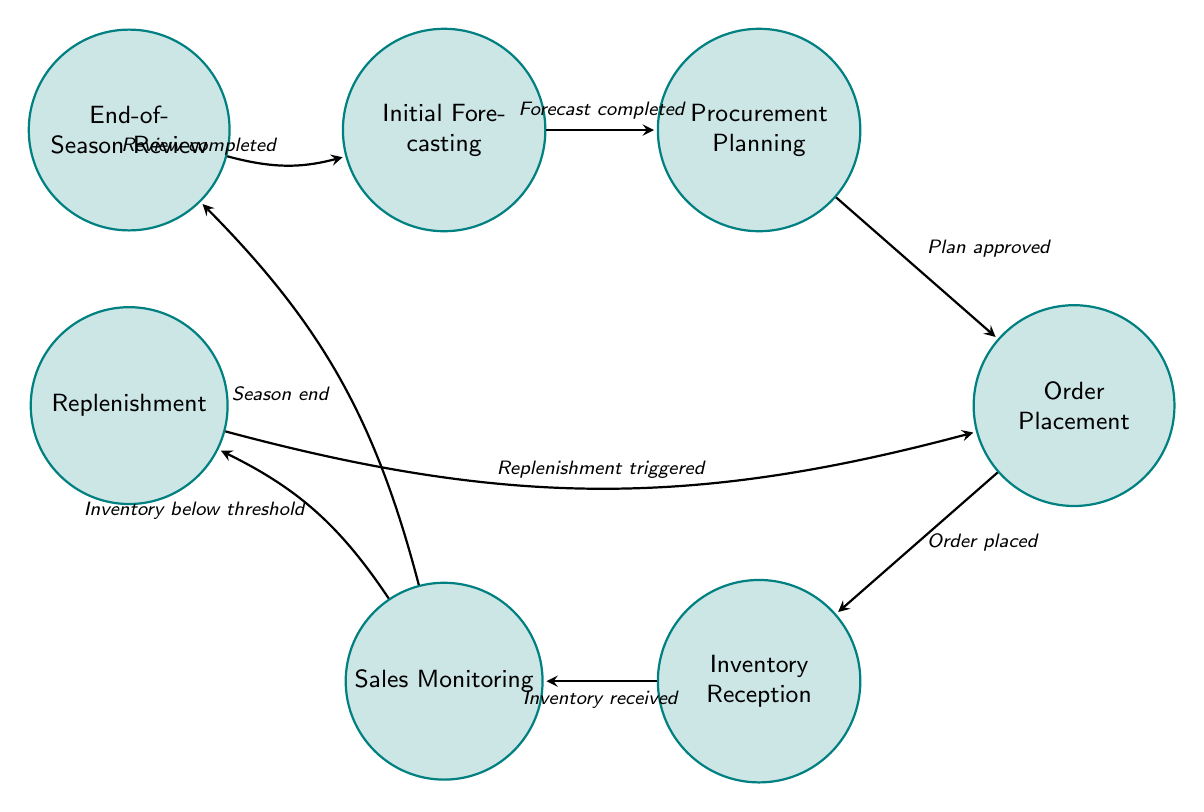What is the first state in the diagram? The first state in the diagram is "Initial Forecasting" as it is the starting point of the flow.
Answer: Initial Forecasting How many nodes are present in the diagram? The diagram contains 7 nodes representing different stages in the inventory management process.
Answer: 7 What is the last state before the “End-of-Season Review”? The last state before "End-of-Season Review" is "Sales Monitoring," as it transitions directly into the review process at the end of the season.
Answer: Sales Monitoring Which state is reached after "Order Placement"? After "Order Placement," the state reached is "Inventory Reception," as indicated by the transition labeled "Order placed."
Answer: Inventory Reception What triggers the transition from "Sales Monitoring" to "Replenishment"? The transition from "Sales Monitoring" to "Replenishment" is triggered by the condition "Inventory below threshold." This means that if the inventory levels fall below a specified limit, this transition occurs.
Answer: Inventory below threshold What is the final action taken in the process? The final action taken in the process is "Review completed," which indicates the conclusion of the "End-of-Season Review" and allows for the cycle to restart at "Initial Forecasting."
Answer: Review completed What represents the continuous activity in the inventory management process? The continuous activity in the inventory management process is represented by "Sales Monitoring," as it involves ongoing oversight of sales and inventory levels throughout the season.
Answer: Sales Monitoring 